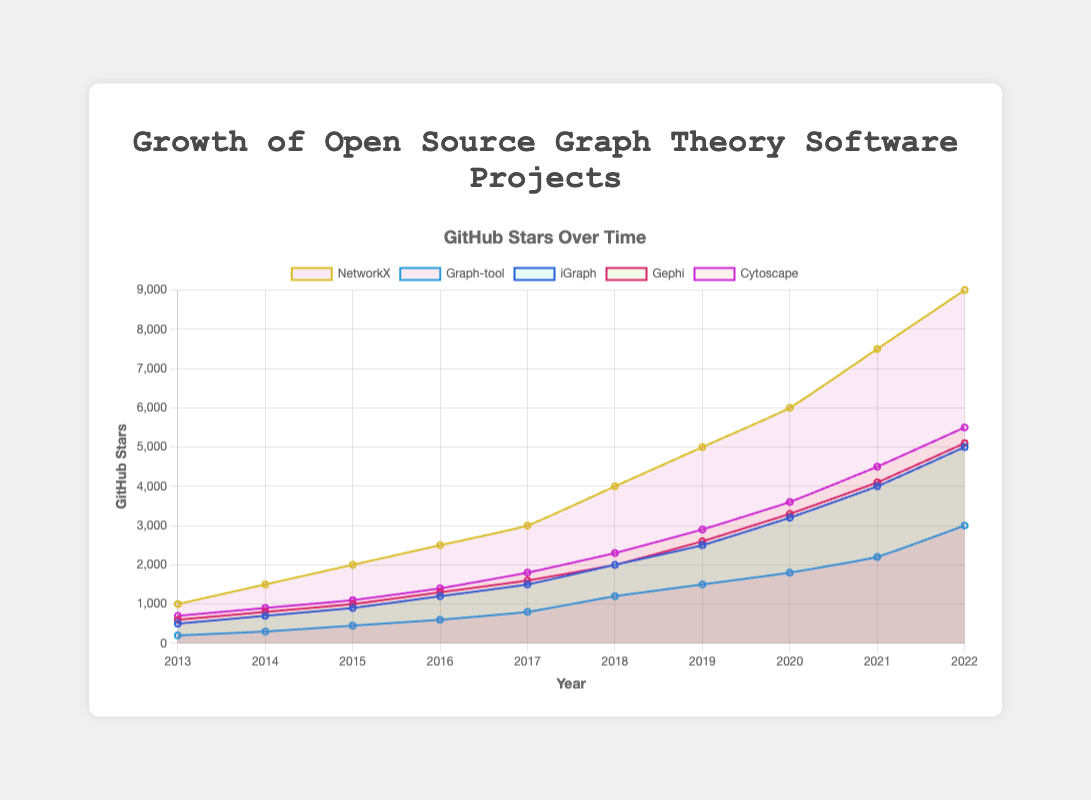What was the total increase in GitHub stars for NetworkX from 2013 to 2022? To find the total increase, subtract the number of stars in 2013 from the number of stars in 2022: 9000 - 1000 = 8000.
Answer: 8000 Which project had the highest number of active contributors in 2022? By observing the number of active contributors in 2022 for each project: NetworkX (50), Graph-tool (35), iGraph (42), Gephi (43), and Cytoscape (50), both NetworkX and Cytoscape had the highest number of active contributors, which is 50.
Answer: NetworkX and Cytoscape In which year did Gephi surpass 2000 GitHub stars? By examining the trend of Gephi's GitHub stars: Gephi surpasses 2000 stars in 2018.
Answer: 2018 Which project had the steepest growth in GitHub stars from 2019 to 2020? By calculating the difference in GitHub stars from 2019 to 2020 for each project: 
NetworkX (6000 - 5000 = 1000), Graph-tool (1800 - 1500 = 300), iGraph (3200 - 2500 = 700), Gephi (3300 - 2600 = 700), Cytoscape (3600 - 2900 = 700). NetworkX saw the steepest growth with an increase of 1000 stars.
Answer: NetworkX Between NetworkX and iGraph, which project had more GitHub stars in 2017? Observing the 2017 GitHub stars for both projects: NetworkX had 3000 stars and iGraph had 1500 stars. NetworkX had more stars.
Answer: NetworkX What is the average number of active contributors for Graph-tool from 2013 to 2022? Sum the active contributors for Graph-tool from 2013 to 2022: (5 + 6 + 9 + 12 + 14 + 18 + 22 + 25 + 30 + 35) = 176, then divide by 10: 176/10 = 17.6.
Answer: 17.6 Which year saw the highest increase in active contributors for Cytoscape? Calculate the year-over-year increases in active contributors for Cytoscape:
2014 (13-10 = 3), 2015 (15-13 = 2), 2016 (18-15 = 3), 2017 (20-18 = 2), 2018 (24-20 = 4), 2019 (29-24 = 5), 2020 (35-29 = 6), 2021 (42-35 = 7), 2022 (50-42 = 8). The highest increase occurred in 2022 with an increase of 8.
Answer: 2022 If you were to compare iGraph's GitHub stars to Gephi's in 2019, which project had more stars? Examining the GitHub stars for iGraph and Gephi in 2019: iGraph had 2500 and Gephi had 2600. Gephi had more stars.
Answer: Gephi How does the visual height of NetworkX's line compare to other projects' lines in the chart? NetworkX's line is generally higher than the other projects' lines, indicating it had more GitHub stars over most of the period.
Answer: Higher 